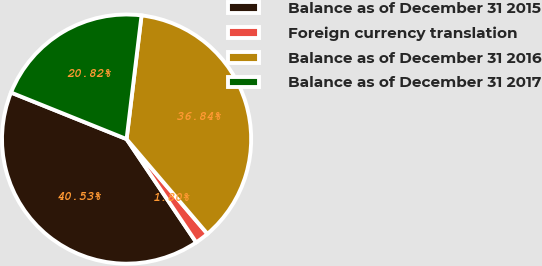<chart> <loc_0><loc_0><loc_500><loc_500><pie_chart><fcel>Balance as of December 31 2015<fcel>Foreign currency translation<fcel>Balance as of December 31 2016<fcel>Balance as of December 31 2017<nl><fcel>40.53%<fcel>1.8%<fcel>36.84%<fcel>20.82%<nl></chart> 